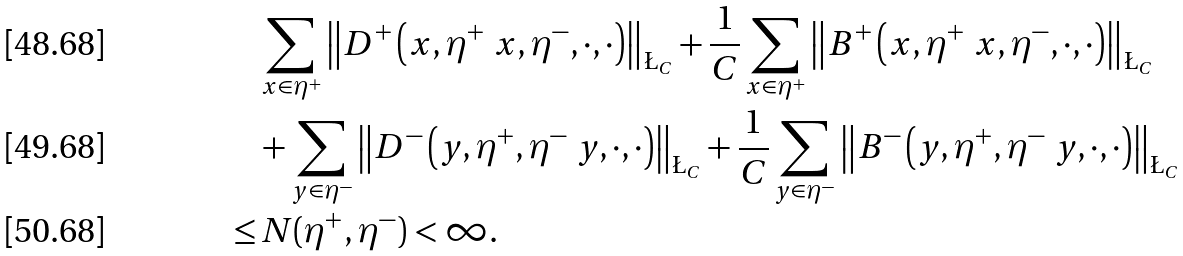<formula> <loc_0><loc_0><loc_500><loc_500>& \sum _ { x \in \eta ^ { + } } \left \| D ^ { + } \left ( x , \eta ^ { + } \ x , \eta ^ { - } , \cdot , \cdot \right ) \right \| _ { \L _ { C } } + \frac { 1 } { C } \sum _ { x \in \eta ^ { + } } \left \| B ^ { + } \left ( x , \eta ^ { + } \ x , \eta ^ { - } , \cdot , \cdot \right ) \right \| _ { \L _ { C } } \\ & + \sum _ { y \in \eta ^ { - } } \left \| D ^ { - } \left ( y , \eta ^ { + } , \eta ^ { - } \ y , \cdot , \cdot \right ) \right \| _ { \L _ { C } } + \frac { 1 } { C } \sum _ { y \in \eta ^ { - } } \left \| B ^ { - } \left ( y , \eta ^ { + } , \eta ^ { - } \ y , \cdot , \cdot \right ) \right \| _ { \L _ { C } } \\ \leq & \, N ( \eta ^ { + } , \eta ^ { - } ) < \infty .</formula> 